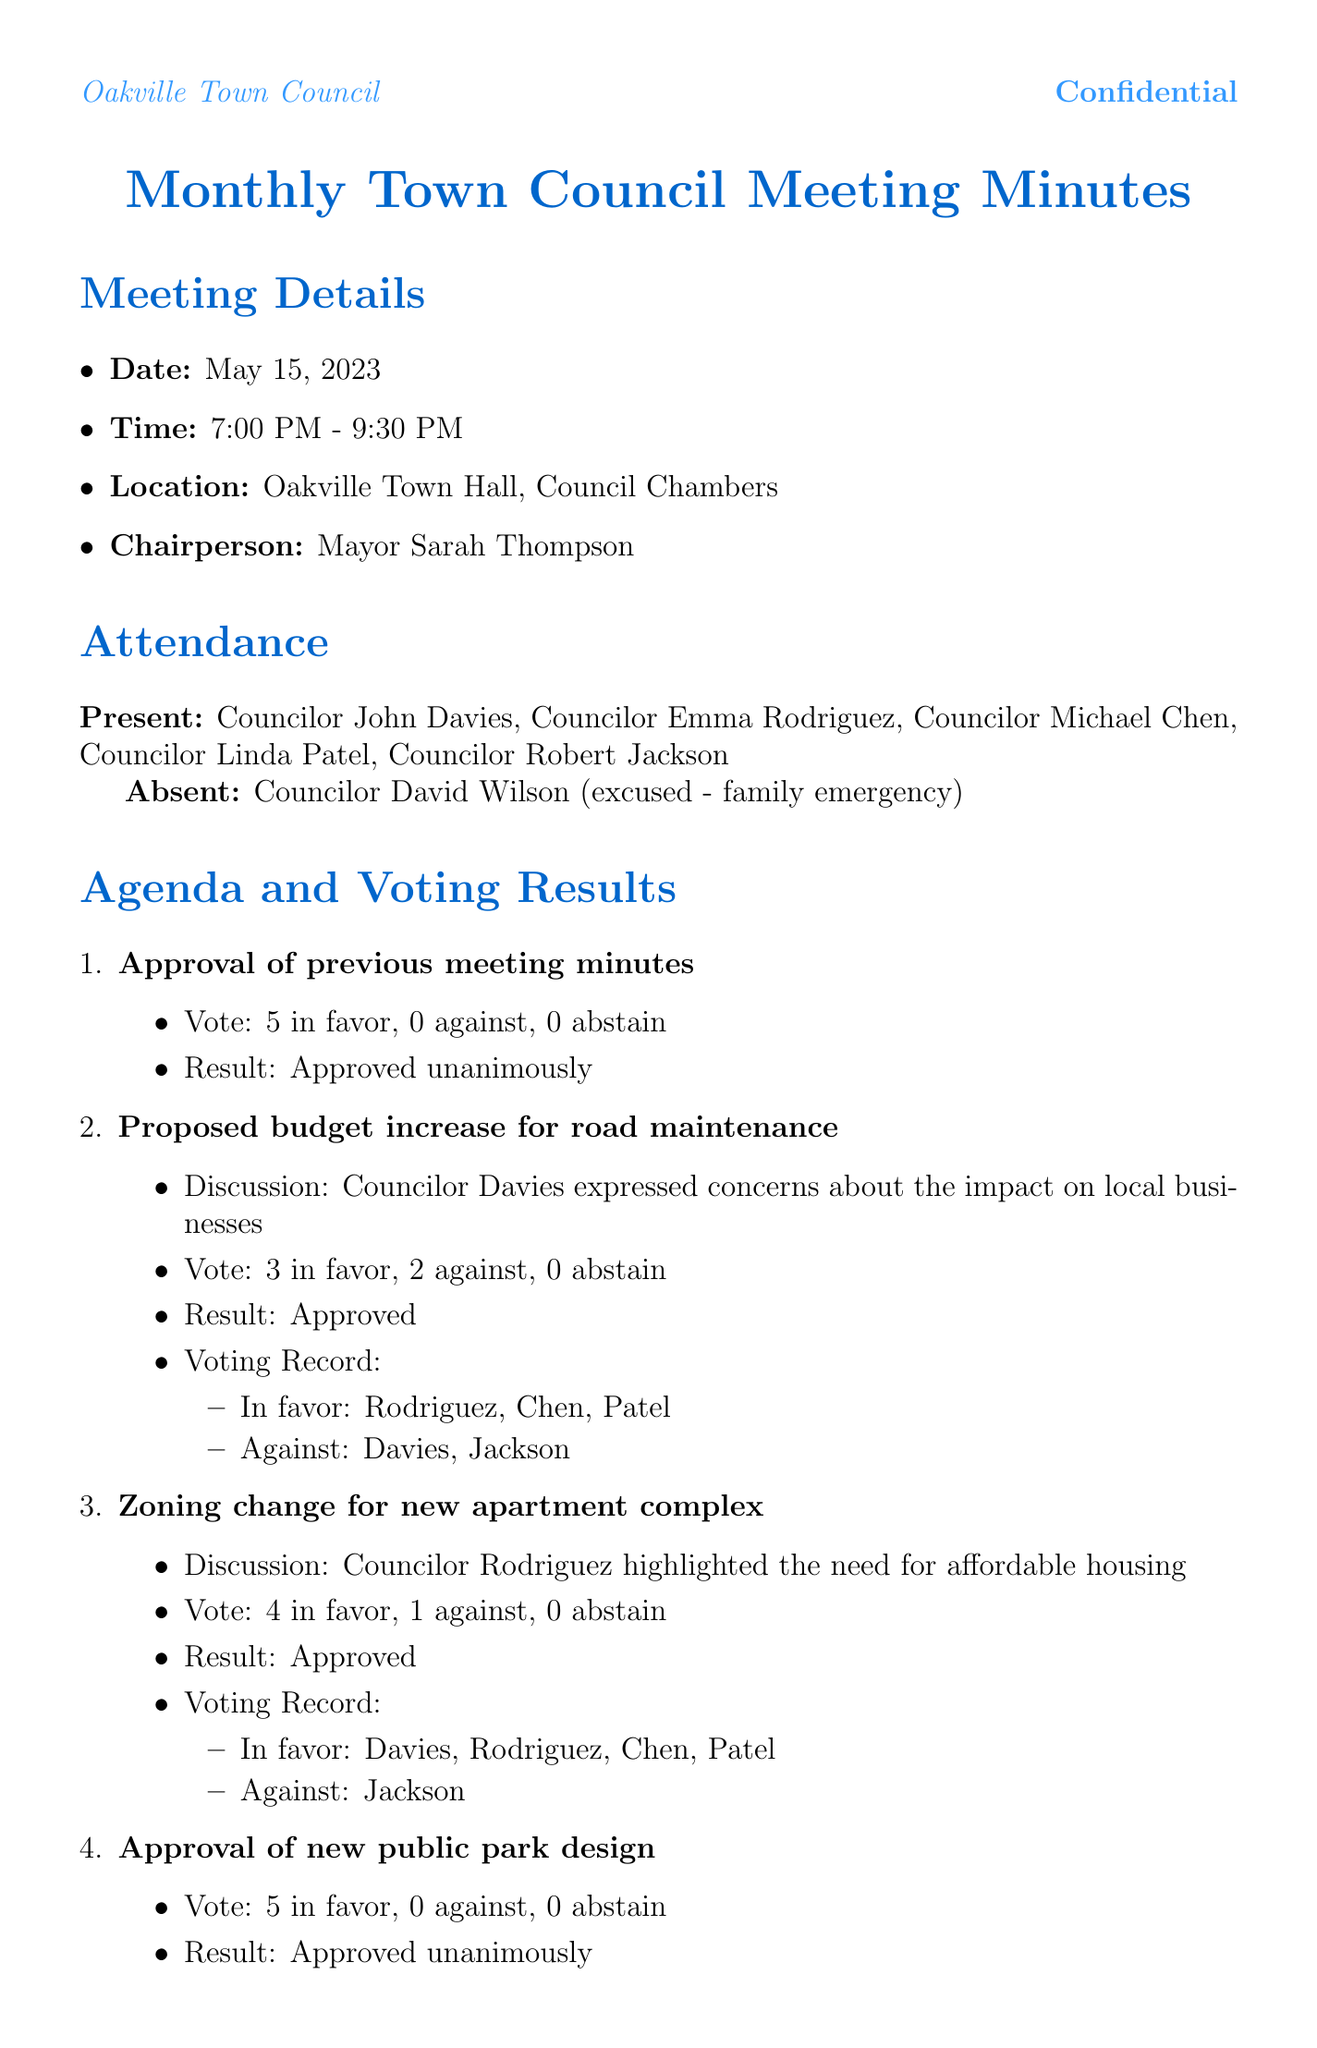What is the date of the meeting? The date of the meeting is explicitly stated in the document.
Answer: May 15, 2023 Who chaired the meeting? The chairperson is mentioned in the meeting details section of the document.
Answer: Mayor Sarah Thompson How many councilors were present at the meeting? The attendance section lists the councilors present at the meeting.
Answer: 5 What was the result of the vote on the zoning change for the new apartment complex? The outcome of this specific vote is detailed in the agenda section of the document.
Answer: Approved Which councilor expressed concerns about the road maintenance budget increase? The discussions for each agenda item contain the names of the councilors who spoke.
Answer: Councilor Davies What was the topic of Jane Smith's public comment? The public comments section specifies the topics addressed by the speakers.
Answer: Increased traffic due to new apartment complex What is the proposed date for the next meeting? The next meeting's details are provided at the end of the document.
Answer: June 19, 2023 Which councilor voted against the zoning change for the new apartment complex? The voting record for this agenda item provides details on who voted in favor and against.
Answer: Councilor Jackson Who authored the confidential notes? The document specifies the author of the confidential notes explicitly.
Answer: Emily Green (Office Clerk) 